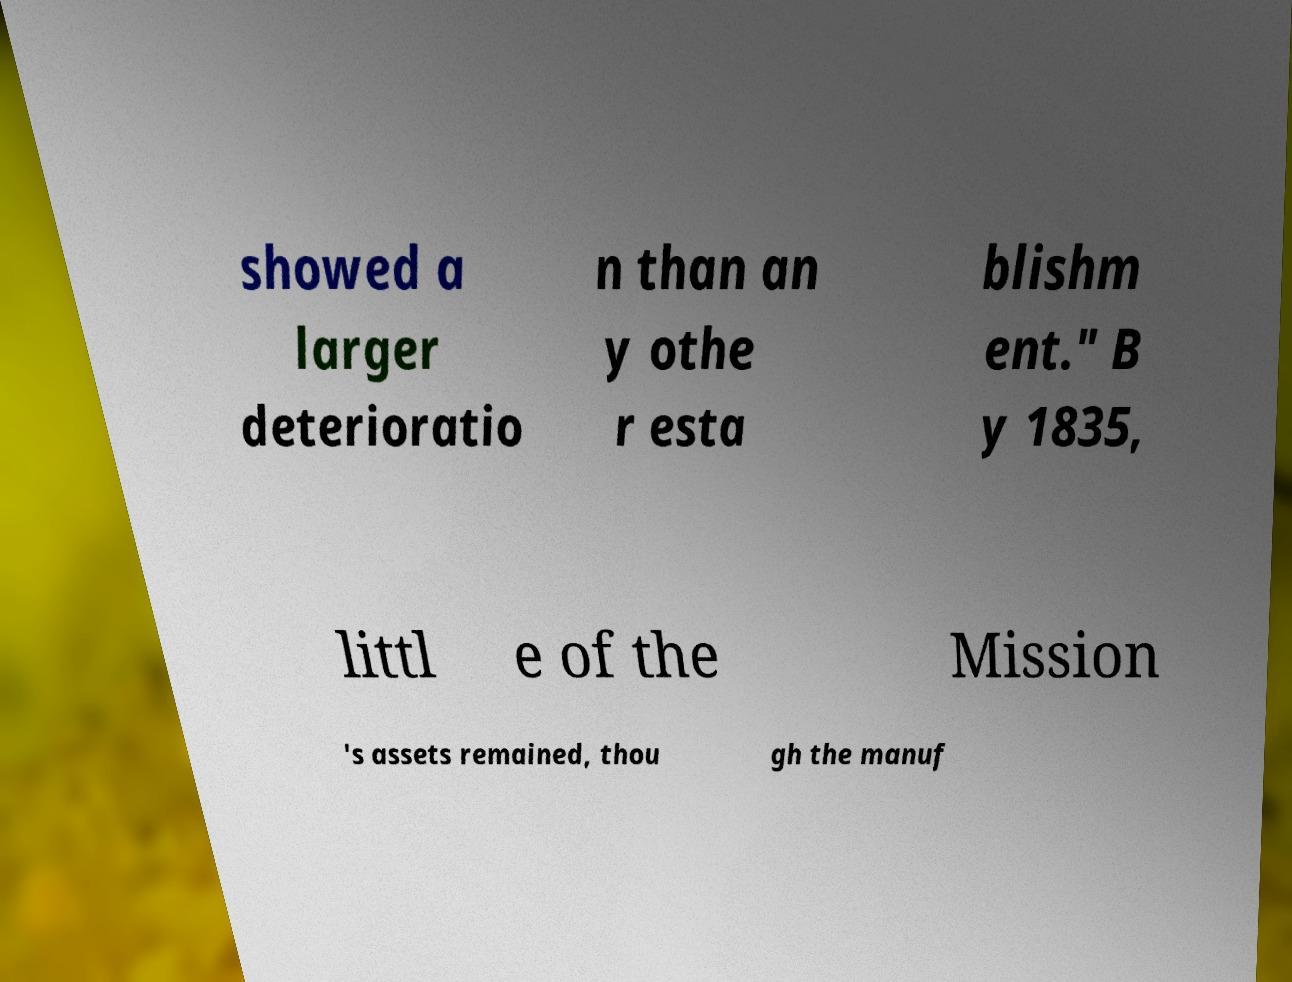What messages or text are displayed in this image? I need them in a readable, typed format. showed a larger deterioratio n than an y othe r esta blishm ent." B y 1835, littl e of the Mission 's assets remained, thou gh the manuf 